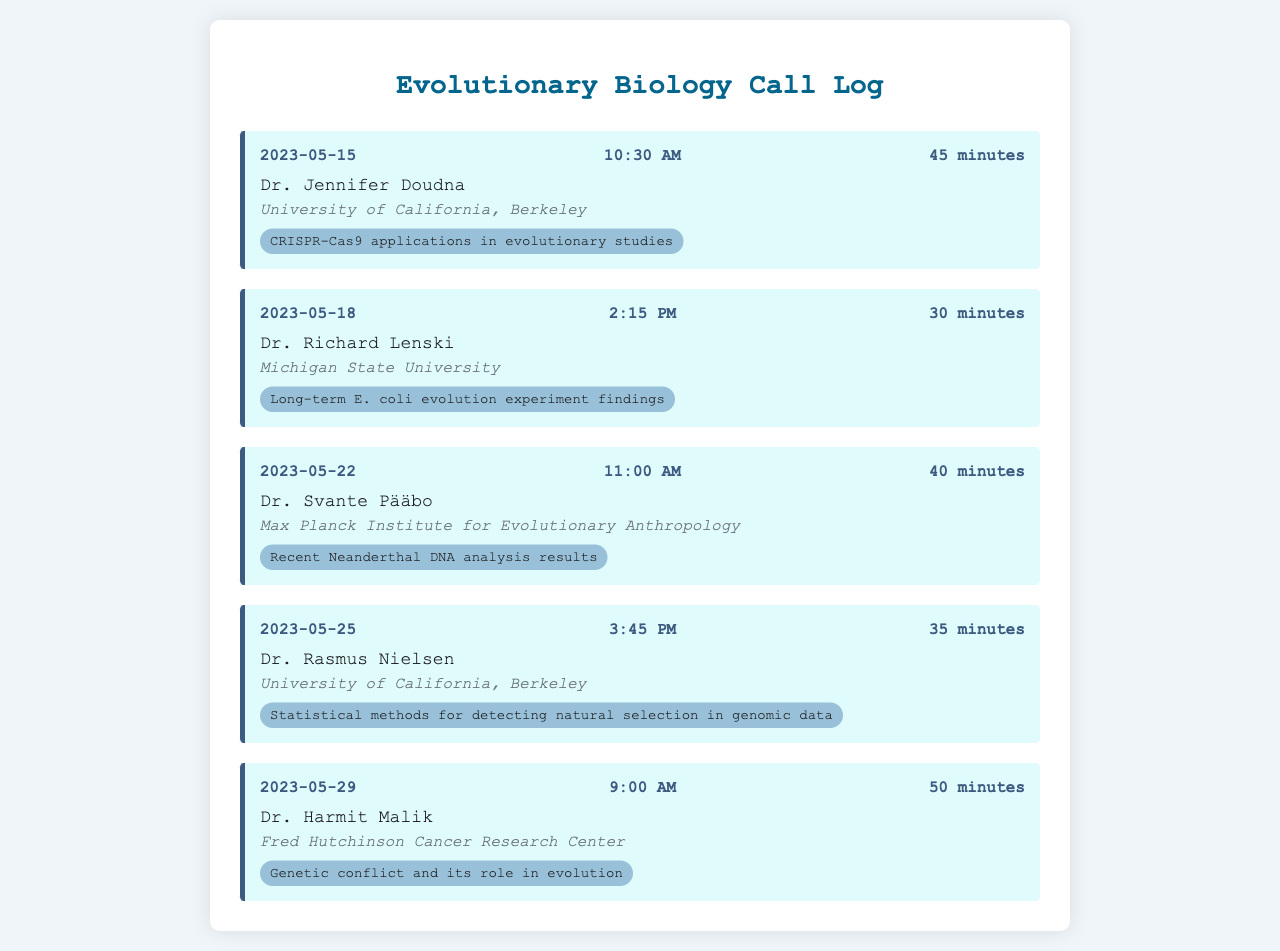What is the date of the call with Dr. Jennifer Doudna? The date of the call is listed in the log for Dr. Jennifer Doudna.
Answer: 2023-05-15 What topic did Dr. Richard Lenski discuss? The topic for Dr. Richard Lenski is mentioned in his call entry details.
Answer: Long-term E. coli evolution experiment findings How long was the call with Dr. Svante Pääbo? The duration of the call with Dr. Svante Pääbo is clearly stated in the document.
Answer: 40 minutes Which institution does Dr. Harmit Malik belong to? The institution affiliated with Dr. Harmit Malik is included in the call entry for his discussion.
Answer: Fred Hutchinson Cancer Research Center What was the time of the call with Dr. Rasmus Nielsen? The time of the call is specified in the call entry for Dr. Rasmus Nielsen.
Answer: 3:45 PM How many calls occurred in May 2023? The document lists the dates of all calls, which can be counted to determine how many took place in May 2023.
Answer: 5 What was the topic discussed in the call on May 29? The topic of the call on May 29 is detailed in the log for the call with Dr. Harmit Malik.
Answer: Genetic conflict and its role in evolution Which call lasted the longest? Comparing the duration of each call provides the information needed to identify which one was the longest.
Answer: 50 minutes Who is associated with the University of California, Berkeley? Individuals affiliated with the University of California, Berkeley are listed in the log entries for certain calls.
Answer: Dr. Jennifer Doudna, Dr. Rasmus Nielsen 